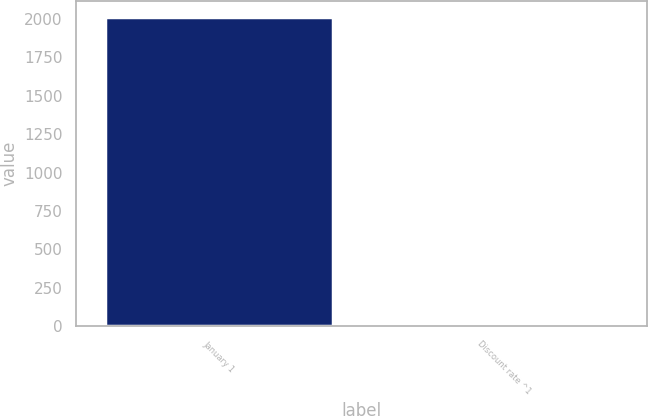Convert chart to OTSL. <chart><loc_0><loc_0><loc_500><loc_500><bar_chart><fcel>January 1<fcel>Discount rate ^1<nl><fcel>2013<fcel>4.1<nl></chart> 